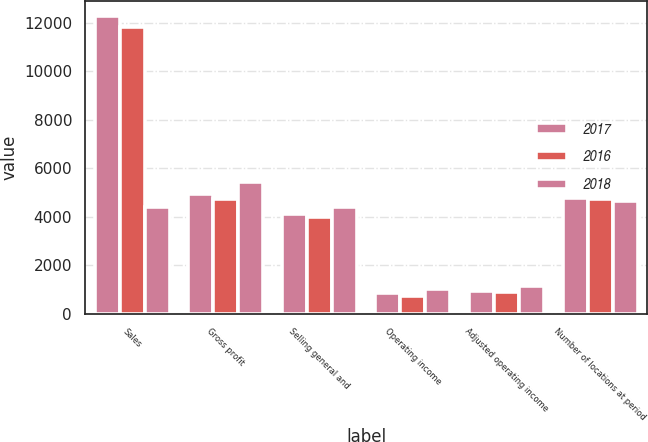Convert chart. <chart><loc_0><loc_0><loc_500><loc_500><stacked_bar_chart><ecel><fcel>Sales<fcel>Gross profit<fcel>Selling general and<fcel>Operating income<fcel>Adjusted operating income<fcel>Number of locations at period<nl><fcel>2017<fcel>12281<fcel>4958<fcel>4116<fcel>842<fcel>947<fcel>4767<nl><fcel>2016<fcel>11813<fcel>4753<fcel>4012<fcel>741<fcel>909<fcel>4722<nl><fcel>2018<fcel>4403<fcel>5432<fcel>4403<fcel>1029<fcel>1155<fcel>4673<nl></chart> 